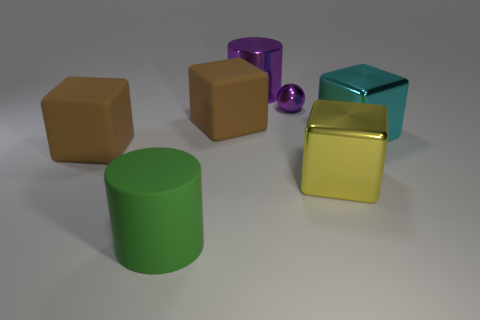Subtract all gray balls. How many brown blocks are left? 2 Subtract 1 cubes. How many cubes are left? 3 Subtract all cyan metal cubes. How many cubes are left? 3 Add 2 large rubber objects. How many objects exist? 9 Subtract all gray blocks. Subtract all red spheres. How many blocks are left? 4 Add 1 tiny rubber cylinders. How many tiny rubber cylinders exist? 1 Subtract 1 yellow blocks. How many objects are left? 6 Subtract all blocks. How many objects are left? 3 Subtract all small gray rubber spheres. Subtract all big metallic things. How many objects are left? 4 Add 4 brown objects. How many brown objects are left? 6 